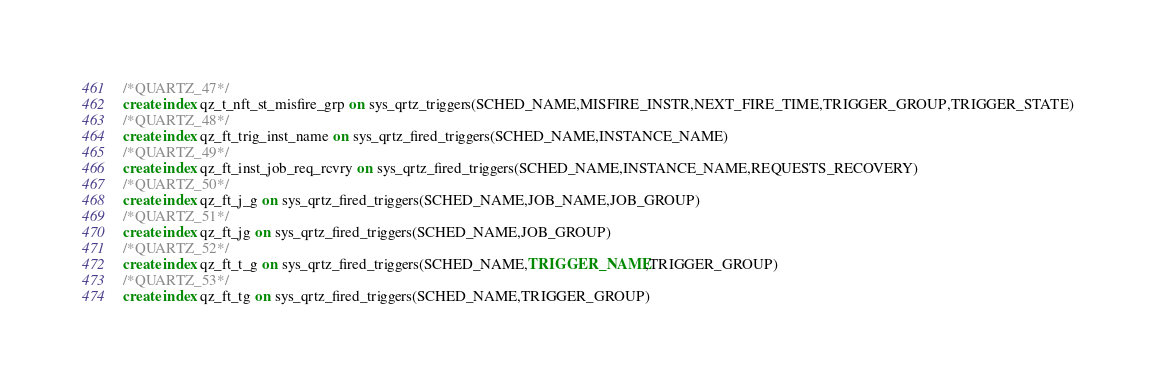<code> <loc_0><loc_0><loc_500><loc_500><_SQL_>/*QUARTZ_47*/
create index qz_t_nft_st_misfire_grp on sys_qrtz_triggers(SCHED_NAME,MISFIRE_INSTR,NEXT_FIRE_TIME,TRIGGER_GROUP,TRIGGER_STATE)
/*QUARTZ_48*/
create index qz_ft_trig_inst_name on sys_qrtz_fired_triggers(SCHED_NAME,INSTANCE_NAME)
/*QUARTZ_49*/
create index qz_ft_inst_job_req_rcvry on sys_qrtz_fired_triggers(SCHED_NAME,INSTANCE_NAME,REQUESTS_RECOVERY)
/*QUARTZ_50*/
create index qz_ft_j_g on sys_qrtz_fired_triggers(SCHED_NAME,JOB_NAME,JOB_GROUP)
/*QUARTZ_51*/
create index qz_ft_jg on sys_qrtz_fired_triggers(SCHED_NAME,JOB_GROUP)
/*QUARTZ_52*/
create index qz_ft_t_g on sys_qrtz_fired_triggers(SCHED_NAME,TRIGGER_NAME,TRIGGER_GROUP)
/*QUARTZ_53*/
create index qz_ft_tg on sys_qrtz_fired_triggers(SCHED_NAME,TRIGGER_GROUP)</code> 